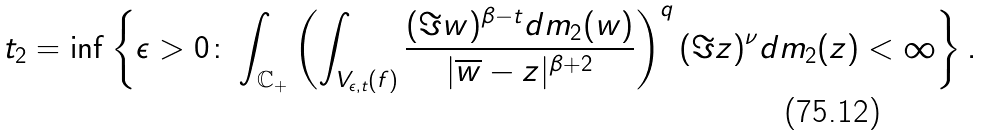Convert formula to latex. <formula><loc_0><loc_0><loc_500><loc_500>t _ { 2 } = \inf \left \{ \epsilon > 0 \colon \int _ { \mathbb { C } _ { + } } \left ( \int _ { V _ { \epsilon , t } ( f ) } \frac { ( \Im w ) ^ { \beta - t } d m _ { 2 } ( w ) } { | \overline { w } - z | ^ { \beta + 2 } } \right ) ^ { q } ( \Im z ) ^ { \nu } d m _ { 2 } ( z ) < \infty \right \} .</formula> 